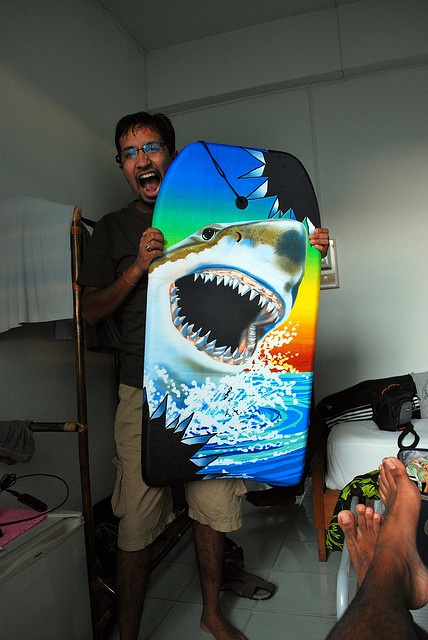Describe the objects in this image and their specific colors. I can see surfboard in black, white, blue, and lightblue tones, people in black, gray, and maroon tones, people in black, maroon, and brown tones, and bed in black, darkgray, lightgray, and maroon tones in this image. 